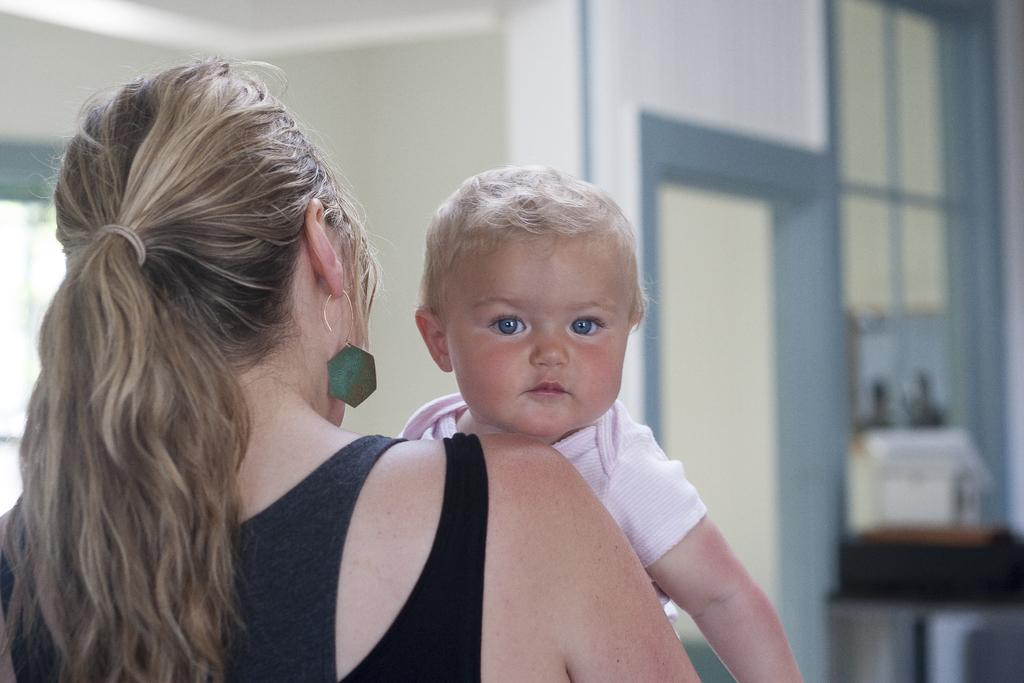How many people are in the image? There are two people in the image. What colors are the dresses worn by the people? One person is wearing a pink dress, and the other person is wearing a black dress. What can be seen in the background of the image? There are objects visible in the background of the image, and there is a wall in the background. What type of soda is the tiger drinking at the station in the image? There is no tiger, soda, or station present in the image. 